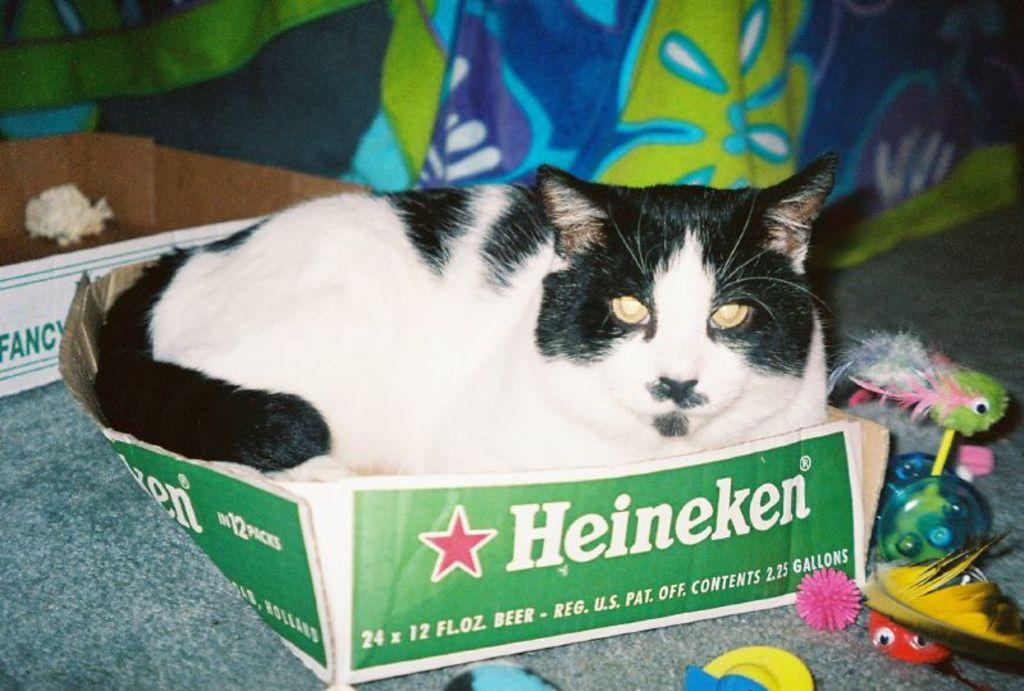<image>
Render a clear and concise summary of the photo. A cat sits in a box originally used for beer. 